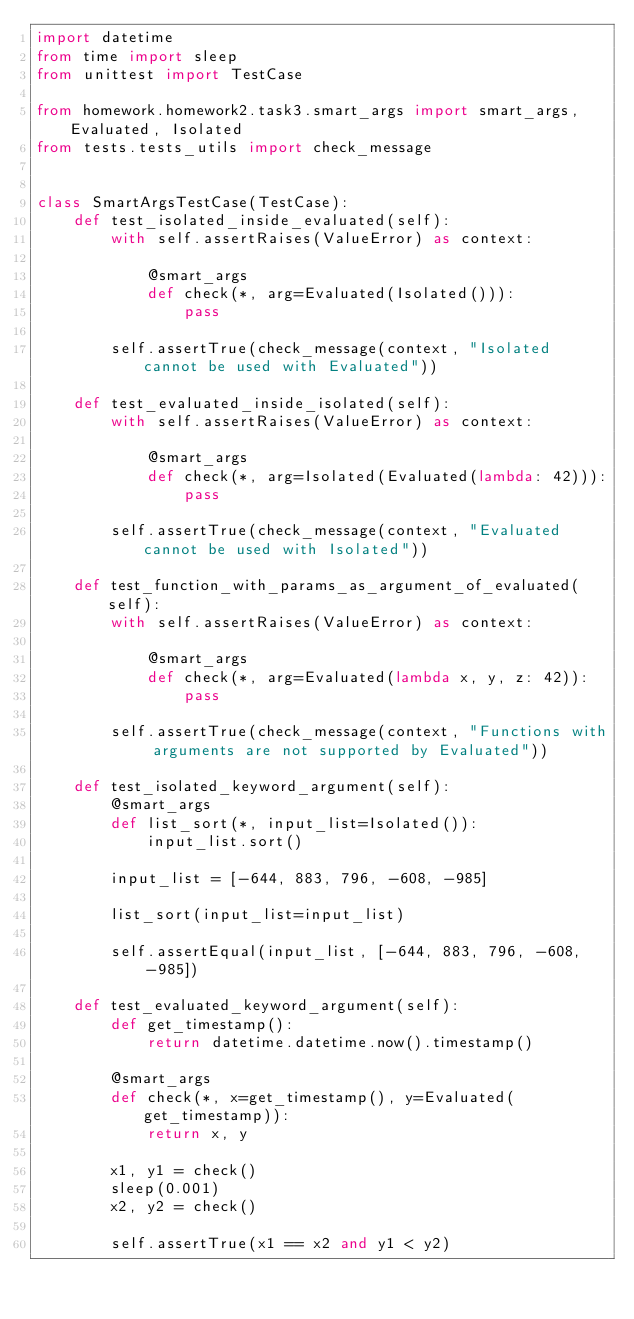Convert code to text. <code><loc_0><loc_0><loc_500><loc_500><_Python_>import datetime
from time import sleep
from unittest import TestCase

from homework.homework2.task3.smart_args import smart_args, Evaluated, Isolated
from tests.tests_utils import check_message


class SmartArgsTestCase(TestCase):
    def test_isolated_inside_evaluated(self):
        with self.assertRaises(ValueError) as context:

            @smart_args
            def check(*, arg=Evaluated(Isolated())):
                pass

        self.assertTrue(check_message(context, "Isolated cannot be used with Evaluated"))

    def test_evaluated_inside_isolated(self):
        with self.assertRaises(ValueError) as context:

            @smart_args
            def check(*, arg=Isolated(Evaluated(lambda: 42))):
                pass

        self.assertTrue(check_message(context, "Evaluated cannot be used with Isolated"))

    def test_function_with_params_as_argument_of_evaluated(self):
        with self.assertRaises(ValueError) as context:

            @smart_args
            def check(*, arg=Evaluated(lambda x, y, z: 42)):
                pass

        self.assertTrue(check_message(context, "Functions with arguments are not supported by Evaluated"))

    def test_isolated_keyword_argument(self):
        @smart_args
        def list_sort(*, input_list=Isolated()):
            input_list.sort()

        input_list = [-644, 883, 796, -608, -985]

        list_sort(input_list=input_list)

        self.assertEqual(input_list, [-644, 883, 796, -608, -985])

    def test_evaluated_keyword_argument(self):
        def get_timestamp():
            return datetime.datetime.now().timestamp()

        @smart_args
        def check(*, x=get_timestamp(), y=Evaluated(get_timestamp)):
            return x, y

        x1, y1 = check()
        sleep(0.001)
        x2, y2 = check()

        self.assertTrue(x1 == x2 and y1 < y2)
</code> 